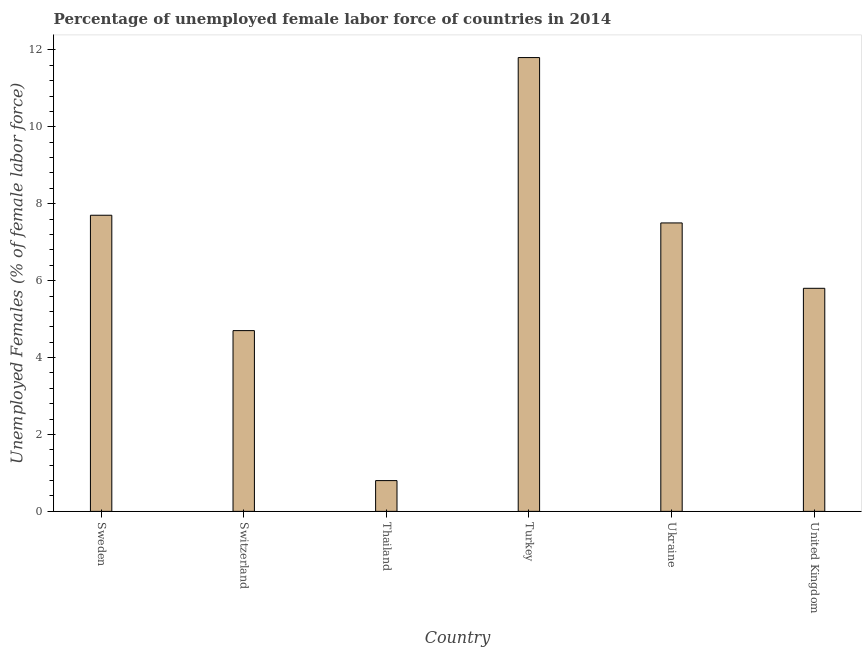Does the graph contain any zero values?
Your answer should be compact. No. What is the title of the graph?
Provide a succinct answer. Percentage of unemployed female labor force of countries in 2014. What is the label or title of the X-axis?
Make the answer very short. Country. What is the label or title of the Y-axis?
Your answer should be very brief. Unemployed Females (% of female labor force). What is the total unemployed female labour force in Turkey?
Ensure brevity in your answer.  11.8. Across all countries, what is the maximum total unemployed female labour force?
Give a very brief answer. 11.8. Across all countries, what is the minimum total unemployed female labour force?
Provide a succinct answer. 0.8. In which country was the total unemployed female labour force maximum?
Make the answer very short. Turkey. In which country was the total unemployed female labour force minimum?
Provide a succinct answer. Thailand. What is the sum of the total unemployed female labour force?
Keep it short and to the point. 38.3. What is the average total unemployed female labour force per country?
Offer a terse response. 6.38. What is the median total unemployed female labour force?
Your answer should be compact. 6.65. What is the ratio of the total unemployed female labour force in Sweden to that in Switzerland?
Your answer should be compact. 1.64. What is the difference between the highest and the second highest total unemployed female labour force?
Provide a succinct answer. 4.1. Is the sum of the total unemployed female labour force in Thailand and United Kingdom greater than the maximum total unemployed female labour force across all countries?
Your response must be concise. No. What is the difference between the highest and the lowest total unemployed female labour force?
Offer a very short reply. 11. How many bars are there?
Your answer should be compact. 6. Are all the bars in the graph horizontal?
Your answer should be compact. No. How many countries are there in the graph?
Make the answer very short. 6. Are the values on the major ticks of Y-axis written in scientific E-notation?
Your response must be concise. No. What is the Unemployed Females (% of female labor force) of Sweden?
Give a very brief answer. 7.7. What is the Unemployed Females (% of female labor force) of Switzerland?
Keep it short and to the point. 4.7. What is the Unemployed Females (% of female labor force) of Thailand?
Your response must be concise. 0.8. What is the Unemployed Females (% of female labor force) in Turkey?
Offer a very short reply. 11.8. What is the Unemployed Females (% of female labor force) of United Kingdom?
Offer a very short reply. 5.8. What is the difference between the Unemployed Females (% of female labor force) in Sweden and Switzerland?
Offer a very short reply. 3. What is the difference between the Unemployed Females (% of female labor force) in Sweden and Turkey?
Give a very brief answer. -4.1. What is the difference between the Unemployed Females (% of female labor force) in Switzerland and Thailand?
Your answer should be compact. 3.9. What is the difference between the Unemployed Females (% of female labor force) in Switzerland and Turkey?
Provide a short and direct response. -7.1. What is the difference between the Unemployed Females (% of female labor force) in Switzerland and Ukraine?
Your answer should be compact. -2.8. What is the difference between the Unemployed Females (% of female labor force) in Switzerland and United Kingdom?
Provide a short and direct response. -1.1. What is the difference between the Unemployed Females (% of female labor force) in Thailand and Turkey?
Provide a succinct answer. -11. What is the difference between the Unemployed Females (% of female labor force) in Turkey and Ukraine?
Your answer should be compact. 4.3. What is the difference between the Unemployed Females (% of female labor force) in Ukraine and United Kingdom?
Offer a terse response. 1.7. What is the ratio of the Unemployed Females (% of female labor force) in Sweden to that in Switzerland?
Keep it short and to the point. 1.64. What is the ratio of the Unemployed Females (% of female labor force) in Sweden to that in Thailand?
Your answer should be compact. 9.62. What is the ratio of the Unemployed Females (% of female labor force) in Sweden to that in Turkey?
Offer a very short reply. 0.65. What is the ratio of the Unemployed Females (% of female labor force) in Sweden to that in Ukraine?
Offer a very short reply. 1.03. What is the ratio of the Unemployed Females (% of female labor force) in Sweden to that in United Kingdom?
Your answer should be compact. 1.33. What is the ratio of the Unemployed Females (% of female labor force) in Switzerland to that in Thailand?
Give a very brief answer. 5.88. What is the ratio of the Unemployed Females (% of female labor force) in Switzerland to that in Turkey?
Your answer should be compact. 0.4. What is the ratio of the Unemployed Females (% of female labor force) in Switzerland to that in Ukraine?
Your response must be concise. 0.63. What is the ratio of the Unemployed Females (% of female labor force) in Switzerland to that in United Kingdom?
Make the answer very short. 0.81. What is the ratio of the Unemployed Females (% of female labor force) in Thailand to that in Turkey?
Keep it short and to the point. 0.07. What is the ratio of the Unemployed Females (% of female labor force) in Thailand to that in Ukraine?
Offer a terse response. 0.11. What is the ratio of the Unemployed Females (% of female labor force) in Thailand to that in United Kingdom?
Your response must be concise. 0.14. What is the ratio of the Unemployed Females (% of female labor force) in Turkey to that in Ukraine?
Provide a succinct answer. 1.57. What is the ratio of the Unemployed Females (% of female labor force) in Turkey to that in United Kingdom?
Your answer should be compact. 2.03. What is the ratio of the Unemployed Females (% of female labor force) in Ukraine to that in United Kingdom?
Provide a succinct answer. 1.29. 